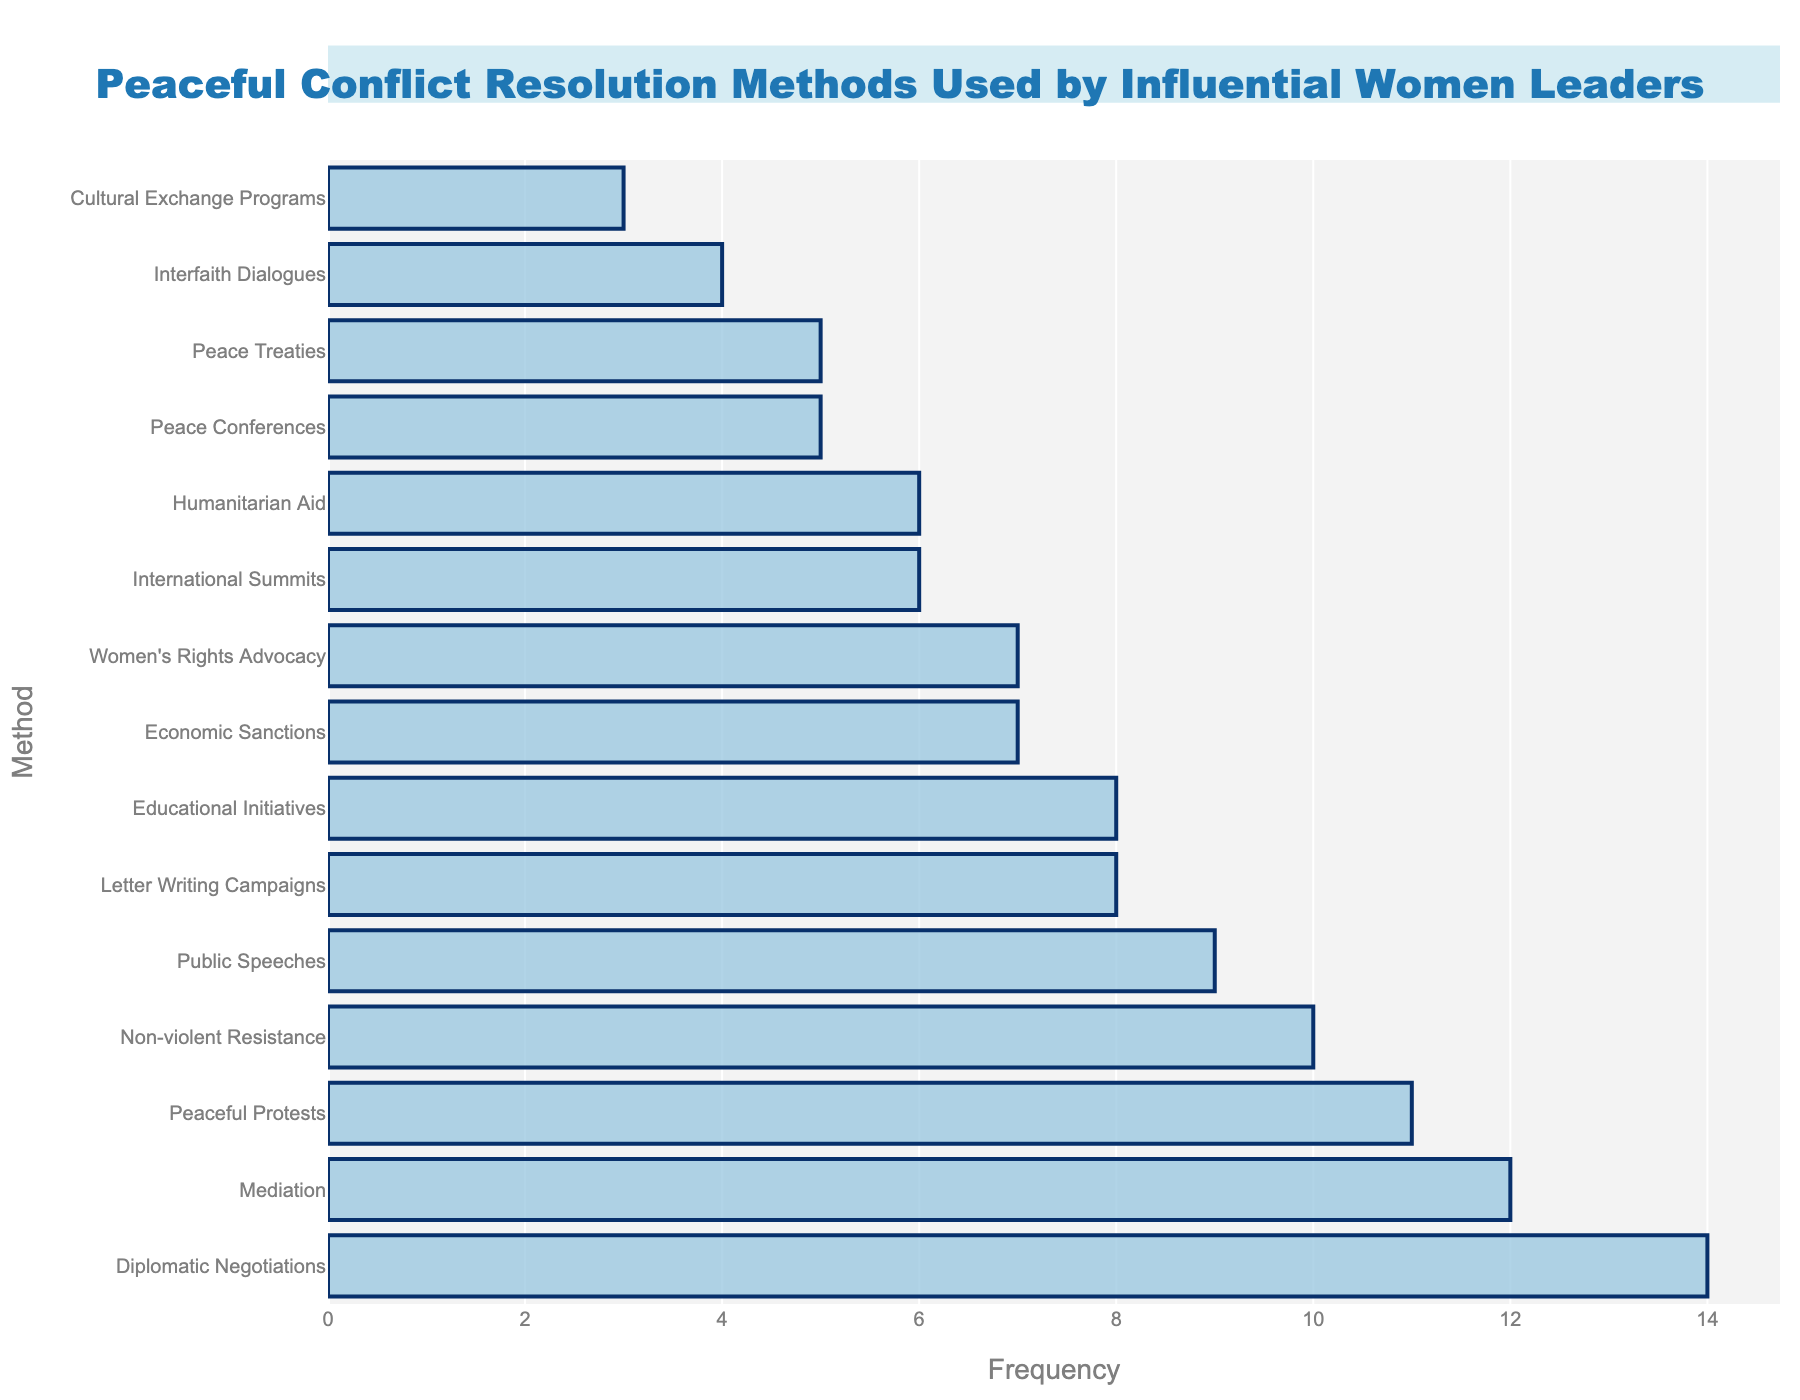Which peaceful conflict resolution method is used most frequently by influential women leaders? Identify the tallest bar in the chart to find the method with the highest frequency. Diplomatic Negotiations has the tallest bar with a frequency of 14.
Answer: Diplomatic Negotiations What is the combined frequency of Economic Sanctions and Women's Rights Advocacy? Find the bars for Economic Sanctions and Women's Rights Advocacy, note their frequencies (7 and 7 respectively), and add them together. 7 + 7 = 14.
Answer: 14 Which method is used less frequently: Mediation or Non-violent Resistance? Compare the heights of the bars for Mediation (12) and Non-violent Resistance (10). Non-violent Resistance has a lower frequency.
Answer: Non-violent Resistance How many methods have a frequency of more than 10? Count the number of bars with frequencies greater than 10. Diplomatic Negotiations (14), Mediation (12), and Peaceful Protests (11) make a total of 3 methods.
Answer: 3 What is the difference in frequency between Public Speeches and Educational Initiatives? Note the frequencies for Public Speeches (9) and Educational Initiatives (8), then subtract 8 from 9. 9 - 8 = 1.
Answer: 1 Which two methods have the same frequency? Identify bars with equal heights. Economic Sanctions and Women's Rights Advocacy both have a frequency of 7.
Answer: Economic Sanctions and Women's Rights Advocacy What is the average frequency of the methods ranked in the top five? Note the frequencies of the top five methods: Diplomatic Negotiations (14), Mediation (12), Peaceful Protests (11), Non-violent Resistance (10), Public Speeches (9). Sum these (14 + 12 + 11 + 10 + 9 = 56), then divide by the number of methods (5). 56/5 = 11.2.
Answer: 11.2 Identify the method with the lowest frequency. Find the shortest bar in the chart. Cultural Exchange Programs has the lowest frequency with 3.
Answer: Cultural Exchange Programs 